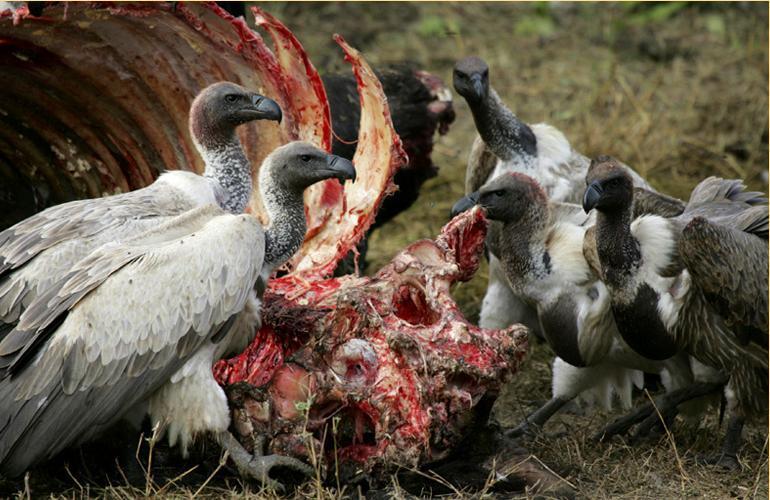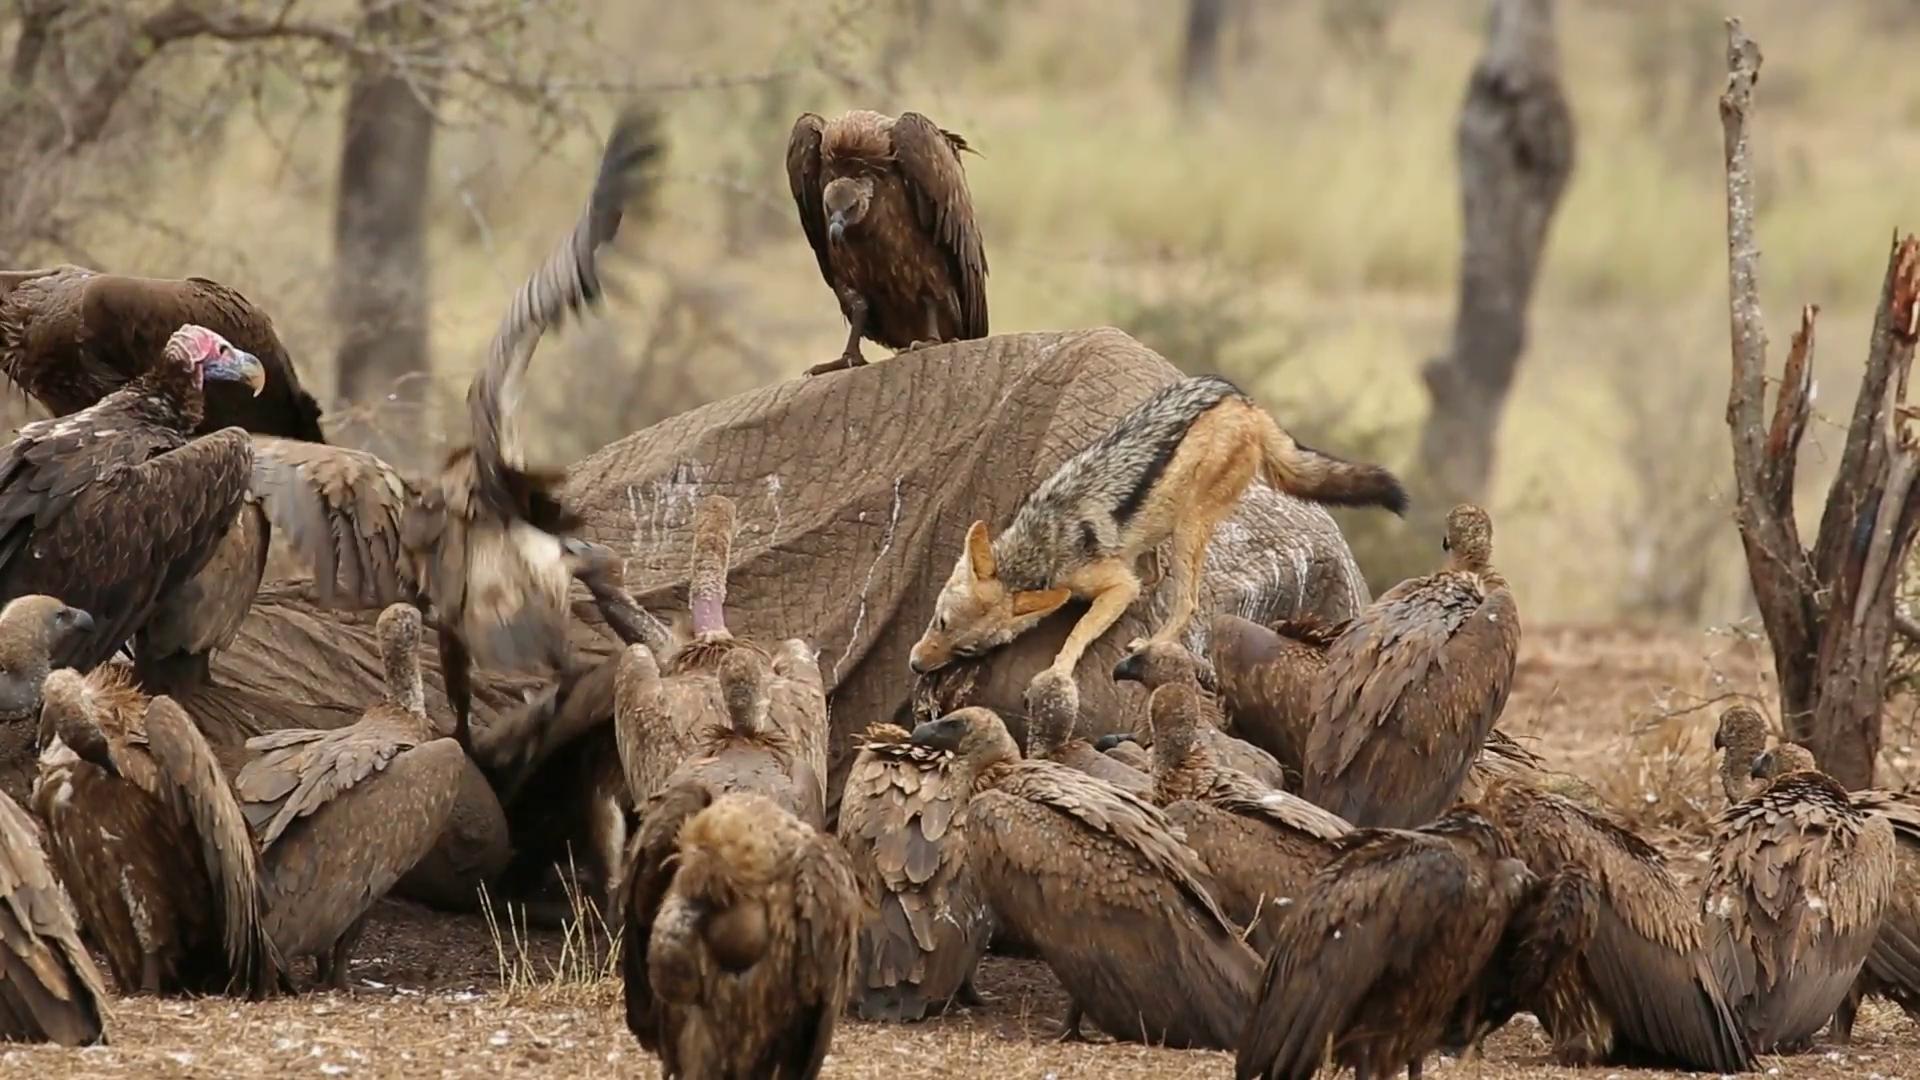The first image is the image on the left, the second image is the image on the right. Assess this claim about the two images: "The left image has the exposed ribcage of an animal carcass.". Correct or not? Answer yes or no. Yes. 